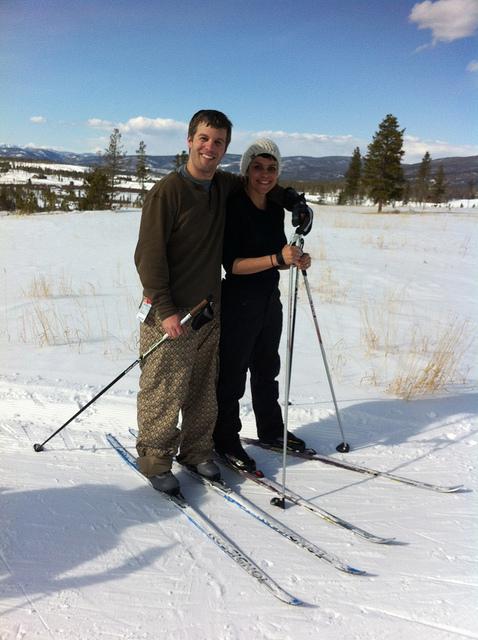What activity are they about to do?
Keep it brief. Ski. Where is the couple wearing their goggles?
Keep it brief. Nowhere. Is it sub freezing outside in the photo?
Be succinct. No. Is the man wearing a coat?
Answer briefly. No. Is the woman featured in this picture wearing protective eye wear?
Write a very short answer. No. Is there a lot of snow on the ground?
Quick response, please. Yes. Is it cold outside?
Give a very brief answer. Yes. 